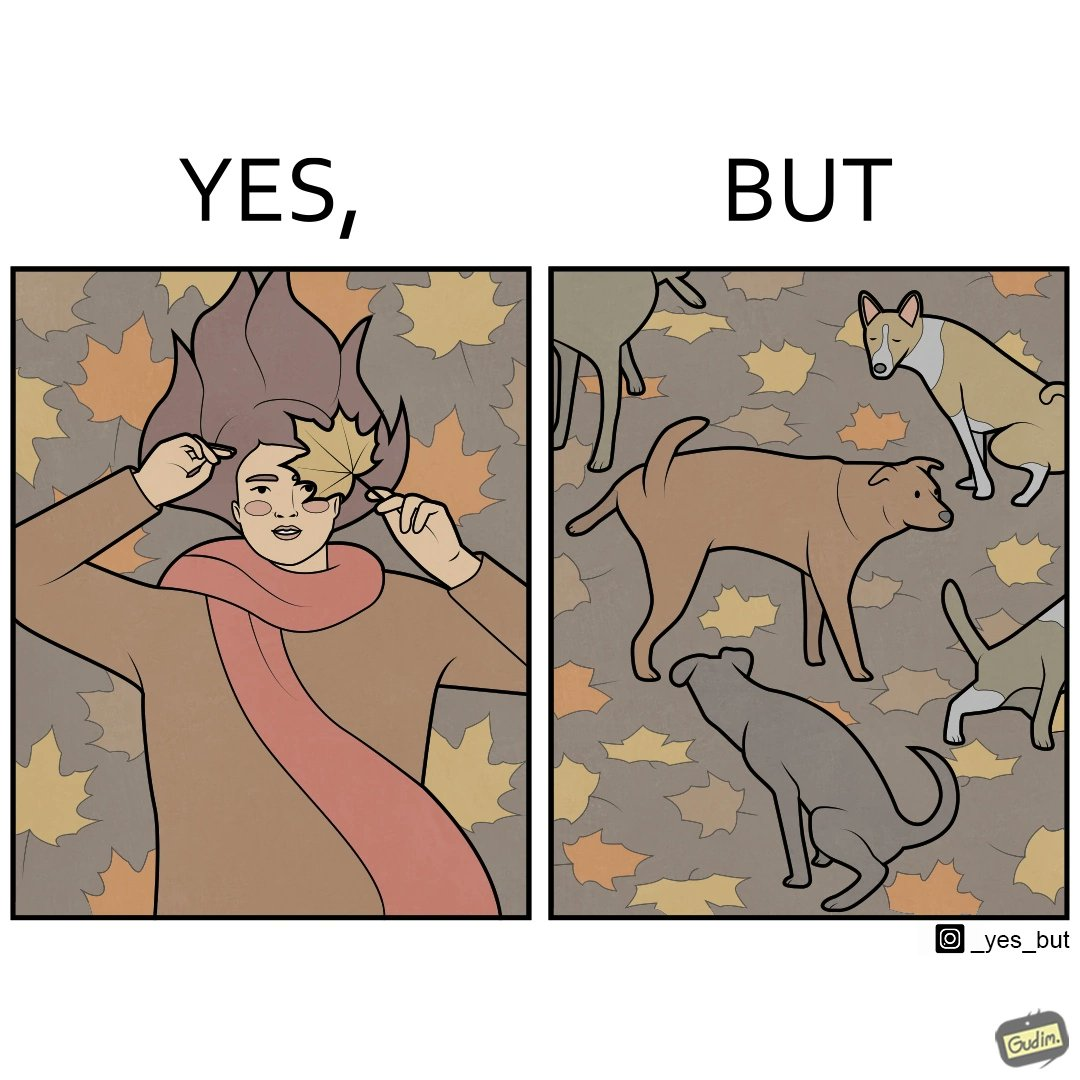Describe the content of this image. The images are funny since it show a woman holding a leaf over half of her face for a good photo but unknown to her is thale fact the same leaf might have been defecated or urinated upon by dogs and other wild animals 